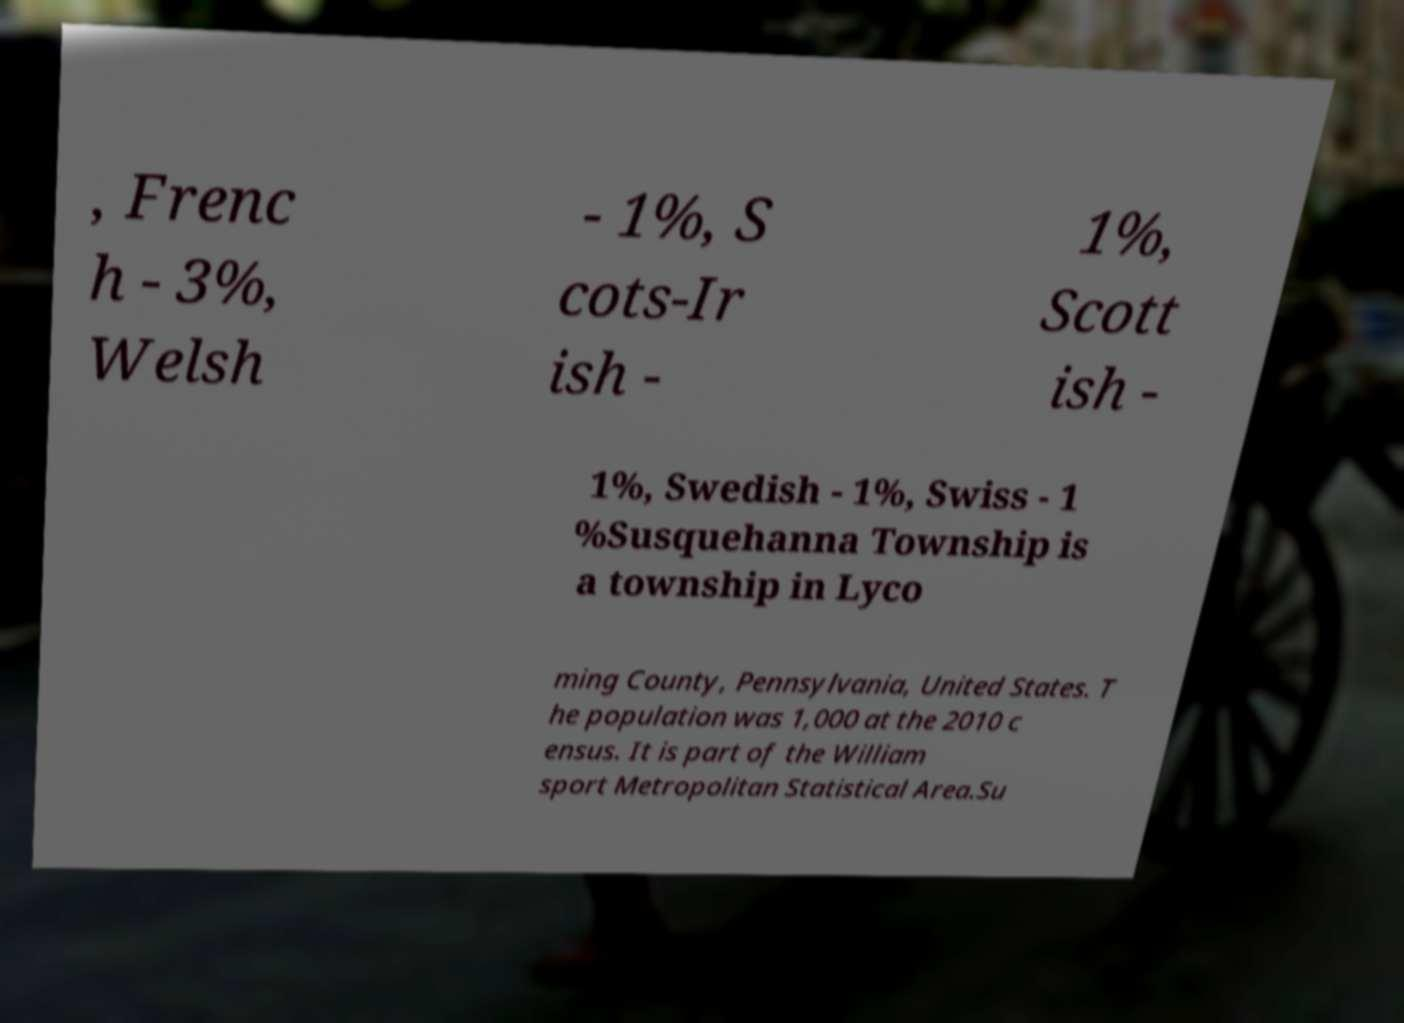Could you extract and type out the text from this image? , Frenc h - 3%, Welsh - 1%, S cots-Ir ish - 1%, Scott ish - 1%, Swedish - 1%, Swiss - 1 %Susquehanna Township is a township in Lyco ming County, Pennsylvania, United States. T he population was 1,000 at the 2010 c ensus. It is part of the William sport Metropolitan Statistical Area.Su 